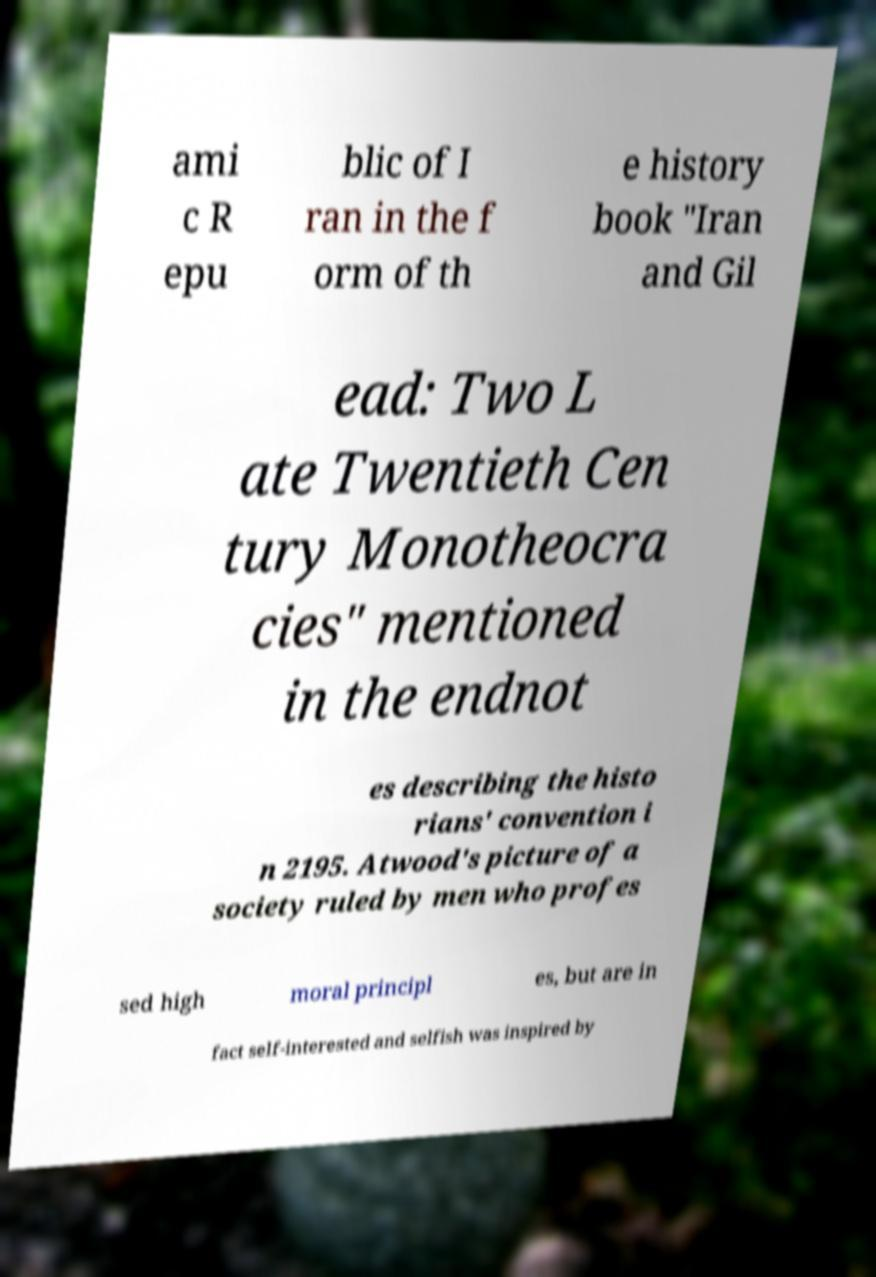Could you extract and type out the text from this image? ami c R epu blic of I ran in the f orm of th e history book "Iran and Gil ead: Two L ate Twentieth Cen tury Monotheocra cies" mentioned in the endnot es describing the histo rians' convention i n 2195. Atwood's picture of a society ruled by men who profes sed high moral principl es, but are in fact self-interested and selfish was inspired by 